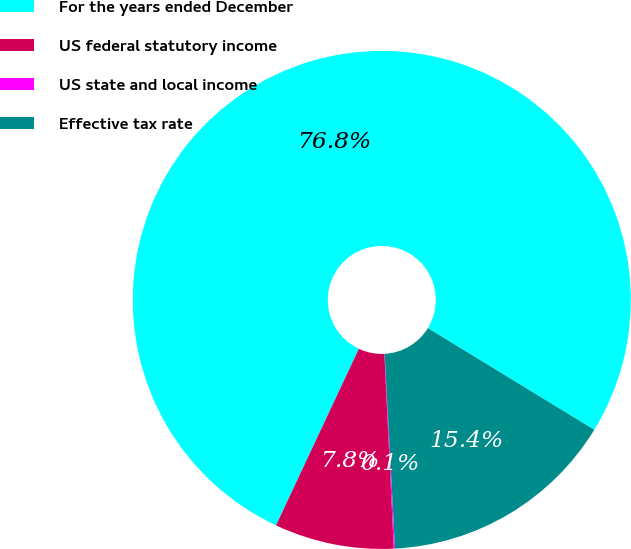Convert chart to OTSL. <chart><loc_0><loc_0><loc_500><loc_500><pie_chart><fcel>For the years ended December<fcel>US federal statutory income<fcel>US state and local income<fcel>Effective tax rate<nl><fcel>76.75%<fcel>7.75%<fcel>0.08%<fcel>15.42%<nl></chart> 